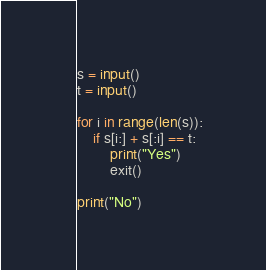Convert code to text. <code><loc_0><loc_0><loc_500><loc_500><_Python_>s = input()
t = input()

for i in range(len(s)):
    if s[i:] + s[:i] == t:
        print("Yes")
        exit()
        
print("No")</code> 